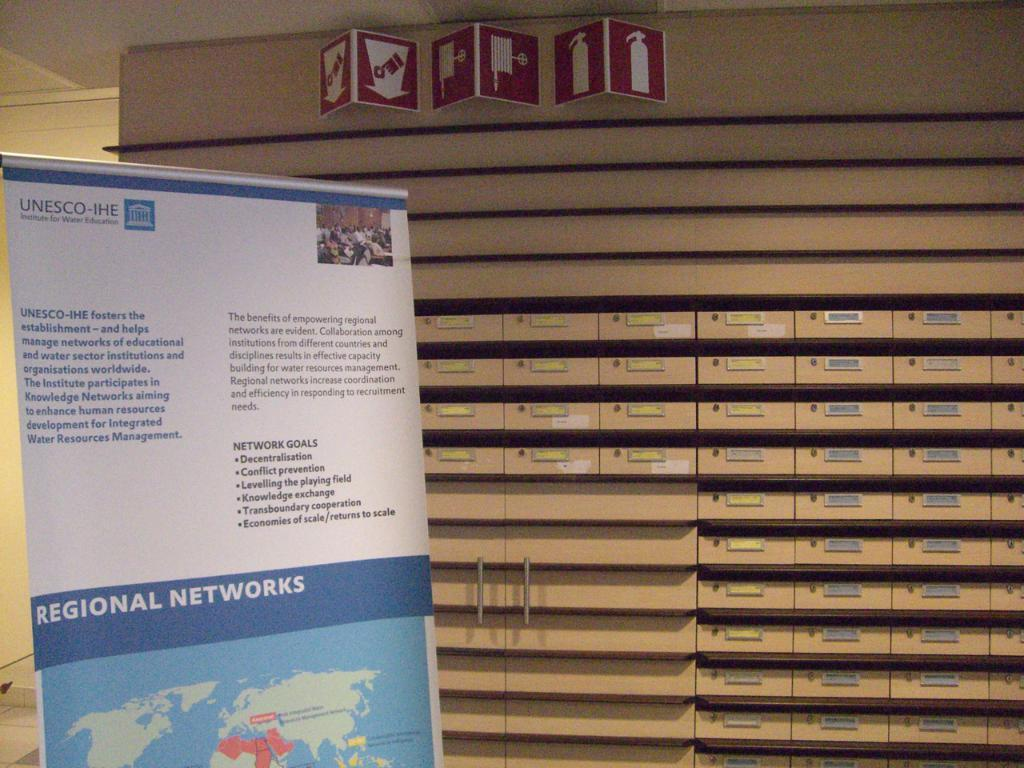<image>
Render a clear and concise summary of the photo. a poster board for regional networks infront of cabinets and small shelves 